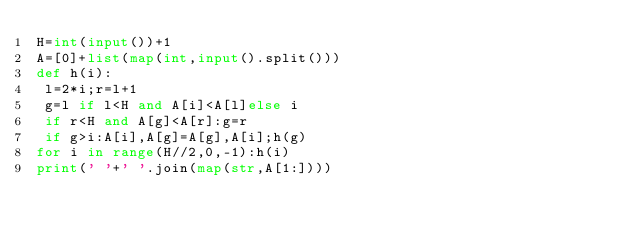<code> <loc_0><loc_0><loc_500><loc_500><_Python_>H=int(input())+1
A=[0]+list(map(int,input().split()))
def h(i):
 l=2*i;r=l+1
 g=l if l<H and A[i]<A[l]else i
 if r<H and A[g]<A[r]:g=r
 if g>i:A[i],A[g]=A[g],A[i];h(g)
for i in range(H//2,0,-1):h(i)
print(' '+' '.join(map(str,A[1:])))
</code> 